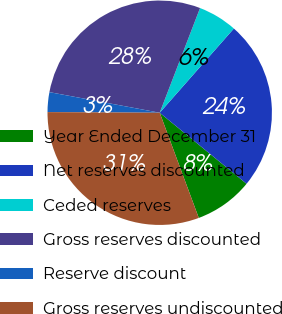Convert chart to OTSL. <chart><loc_0><loc_0><loc_500><loc_500><pie_chart><fcel>Year Ended December 31<fcel>Net reserves discounted<fcel>Ceded reserves<fcel>Gross reserves discounted<fcel>Reserve discount<fcel>Gross reserves undiscounted<nl><fcel>8.43%<fcel>24.42%<fcel>5.64%<fcel>27.91%<fcel>2.85%<fcel>30.75%<nl></chart> 